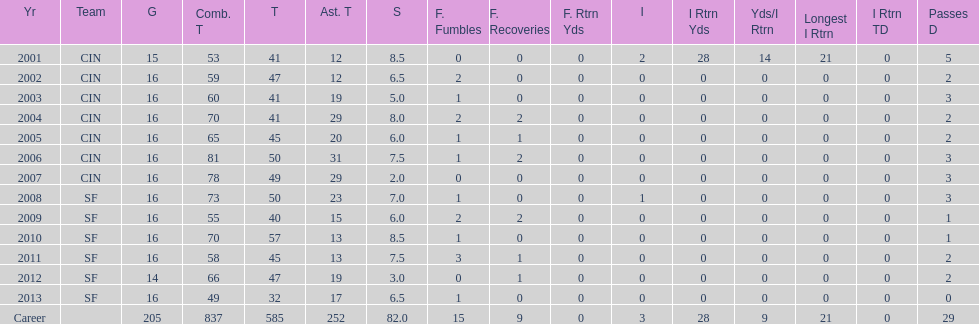What is the total number of sacks smith has made? 82.0. 